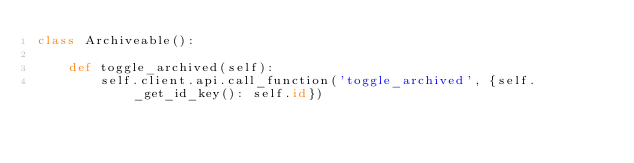Convert code to text. <code><loc_0><loc_0><loc_500><loc_500><_Python_>class Archiveable():

    def toggle_archived(self):
        self.client.api.call_function('toggle_archived', {self._get_id_key(): self.id})
</code> 